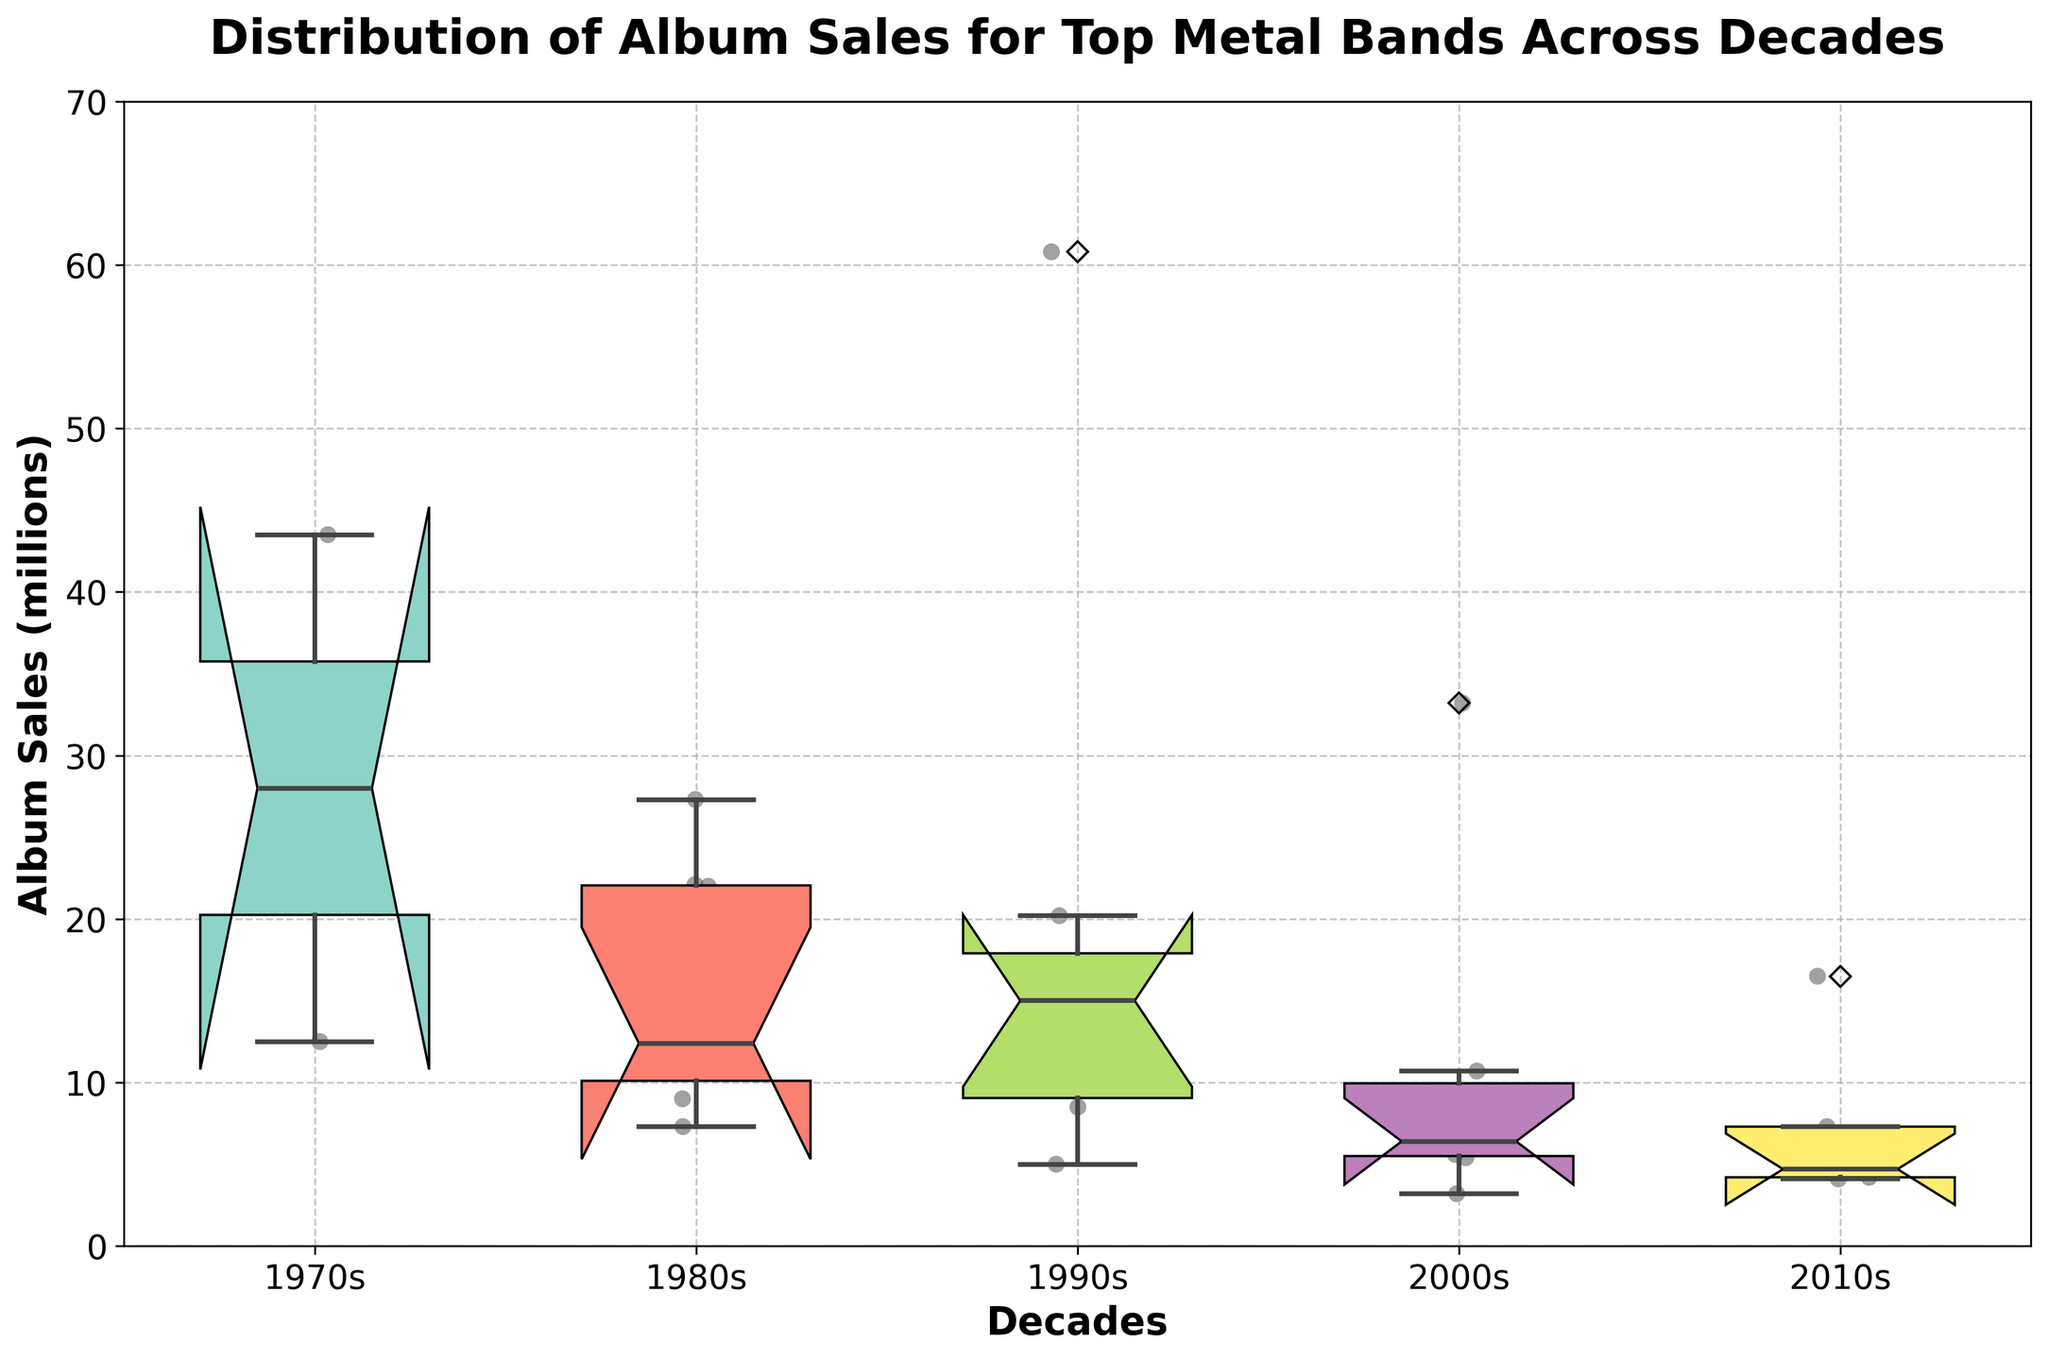What's the title of the plot? The information can be found on the top of the figure which usually states the main subject of the visual representation.
Answer: Distribution of Album Sales for Top Metal Bands Across Decades What are the units of the y-axis? By observing the y-axis label, we can see it specifies the units of measurement used for the data.
Answer: Album Sales (millions) How many decades are represented in the plot? By counting the x-axis labels, which represent distinct categories, we can see the number of decades covered by the data.
Answer: 5 What is the general trend of album sales for the 2010s compared to the 1980s? By comparing the box plots for the 1980s and 2010s on the x-axis, we can see how the quartile ranges and medians differ over these decades.
Answer: Sales decreased Which decade has the widest interquartile range (IQR)? The IQR can be observed by finding the difference between the upper and lower quartiles of each box plot. The decade with the tall enough box has the widest IQR.
Answer: 1980s What is the median album sales for the 1990s? Locate the middle line inside the box corresponding to the 1990s on the x-axis to identify the median value.
Answer: ~15.3 million In which decade is the median album sales the highest? Look for the box plot with the highest median line across all decades to determine where the median sales are the highest.
Answer: 1990s Compare the album sales for Black Sabbath in the 1970s and the 2000s. Which decade had higher sales? By comparing the individual data points plotted for Black Sabbath in the 1970s and 2000s, we can see which group had a higher sales value.
Answer: 1970s How do the sales of Iron Maiden in the 1980s compare to other bands in the same decade? Observe the vertical positions of Iron Maiden's data point in the 1980s relative to the other individual data points and the overall box plot's median range.
Answer: Iron Maiden is above the median Which decades show a decline in album sales for Metallica over time? Trace the plotted data points for Metallica across the decades and note any decreases in sales values.
Answer: 2000s and 2010s 